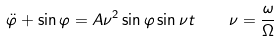<formula> <loc_0><loc_0><loc_500><loc_500>\ddot { \varphi } + \sin \varphi = A \nu ^ { 2 } \sin \varphi \sin \nu t \quad \nu = \frac { \omega } { \Omega }</formula> 